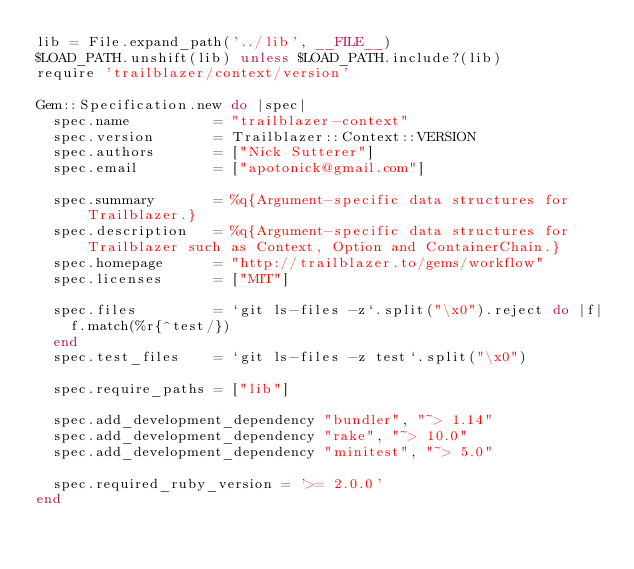Convert code to text. <code><loc_0><loc_0><loc_500><loc_500><_Ruby_>lib = File.expand_path('../lib', __FILE__)
$LOAD_PATH.unshift(lib) unless $LOAD_PATH.include?(lib)
require 'trailblazer/context/version'

Gem::Specification.new do |spec|
  spec.name          = "trailblazer-context"
  spec.version       = Trailblazer::Context::VERSION
  spec.authors       = ["Nick Sutterer"]
  spec.email         = ["apotonick@gmail.com"]

  spec.summary       = %q{Argument-specific data structures for Trailblazer.}
  spec.description   = %q{Argument-specific data structures for Trailblazer such as Context, Option and ContainerChain.}
  spec.homepage      = "http://trailblazer.to/gems/workflow"
  spec.licenses      = ["MIT"]

  spec.files         = `git ls-files -z`.split("\x0").reject do |f|
    f.match(%r{^test/})
  end
  spec.test_files    = `git ls-files -z test`.split("\x0")

  spec.require_paths = ["lib"]

  spec.add_development_dependency "bundler", "~> 1.14"
  spec.add_development_dependency "rake", "~> 10.0"
  spec.add_development_dependency "minitest", "~> 5.0"

  spec.required_ruby_version = '>= 2.0.0'
end
</code> 